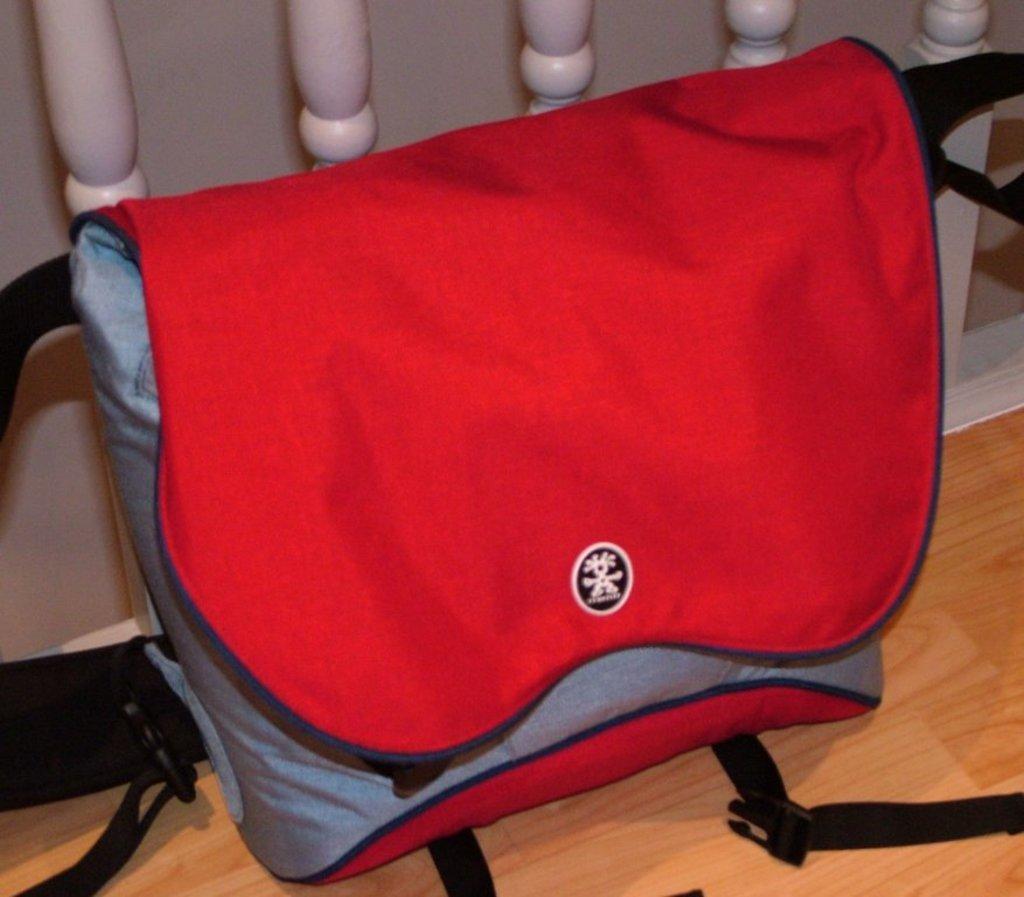Describe this image in one or two sentences. In this image, we can see a bag on the wooden surface. We can also see some white colored objects. 